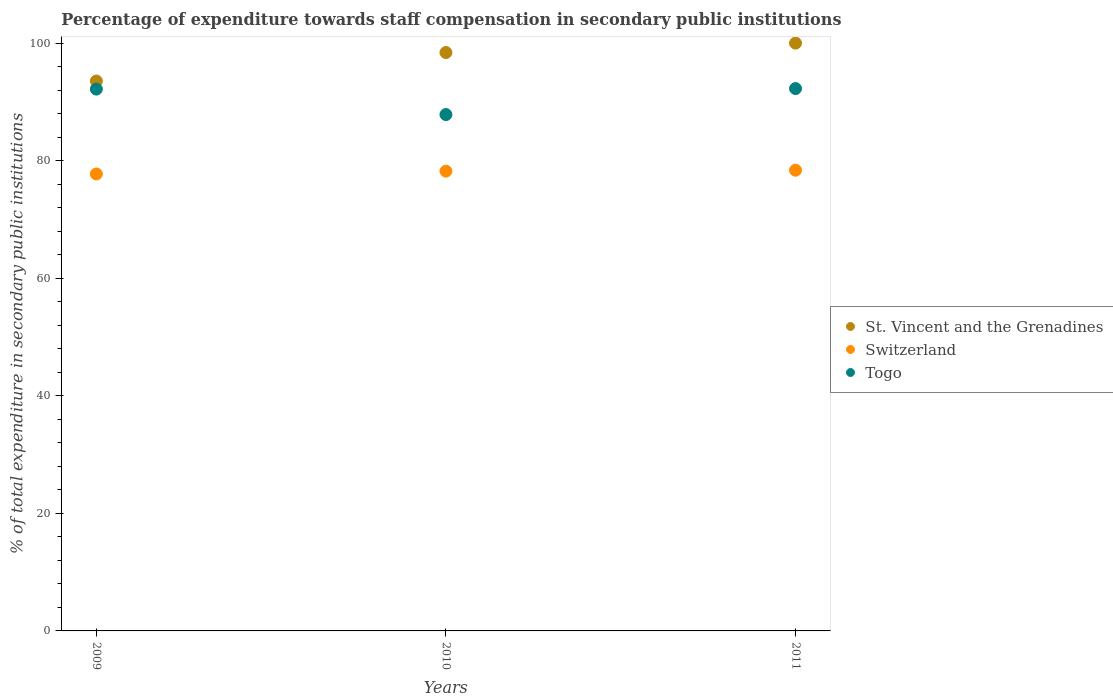How many different coloured dotlines are there?
Provide a short and direct response. 3. What is the percentage of expenditure towards staff compensation in Togo in 2010?
Ensure brevity in your answer.  87.84. Across all years, what is the maximum percentage of expenditure towards staff compensation in Togo?
Your response must be concise. 92.26. Across all years, what is the minimum percentage of expenditure towards staff compensation in Togo?
Your answer should be compact. 87.84. In which year was the percentage of expenditure towards staff compensation in Switzerland maximum?
Make the answer very short. 2011. What is the total percentage of expenditure towards staff compensation in Togo in the graph?
Make the answer very short. 272.29. What is the difference between the percentage of expenditure towards staff compensation in Switzerland in 2009 and that in 2011?
Offer a terse response. -0.64. What is the difference between the percentage of expenditure towards staff compensation in St. Vincent and the Grenadines in 2011 and the percentage of expenditure towards staff compensation in Togo in 2009?
Keep it short and to the point. 7.82. What is the average percentage of expenditure towards staff compensation in Switzerland per year?
Keep it short and to the point. 78.11. In the year 2011, what is the difference between the percentage of expenditure towards staff compensation in St. Vincent and the Grenadines and percentage of expenditure towards staff compensation in Switzerland?
Offer a terse response. 21.62. In how many years, is the percentage of expenditure towards staff compensation in St. Vincent and the Grenadines greater than 56 %?
Your response must be concise. 3. What is the ratio of the percentage of expenditure towards staff compensation in St. Vincent and the Grenadines in 2009 to that in 2010?
Give a very brief answer. 0.95. Is the percentage of expenditure towards staff compensation in St. Vincent and the Grenadines in 2010 less than that in 2011?
Provide a short and direct response. Yes. What is the difference between the highest and the second highest percentage of expenditure towards staff compensation in Togo?
Provide a succinct answer. 0.09. What is the difference between the highest and the lowest percentage of expenditure towards staff compensation in St. Vincent and the Grenadines?
Give a very brief answer. 6.45. In how many years, is the percentage of expenditure towards staff compensation in Togo greater than the average percentage of expenditure towards staff compensation in Togo taken over all years?
Ensure brevity in your answer.  2. Is it the case that in every year, the sum of the percentage of expenditure towards staff compensation in Togo and percentage of expenditure towards staff compensation in St. Vincent and the Grenadines  is greater than the percentage of expenditure towards staff compensation in Switzerland?
Provide a succinct answer. Yes. Is the percentage of expenditure towards staff compensation in St. Vincent and the Grenadines strictly less than the percentage of expenditure towards staff compensation in Switzerland over the years?
Make the answer very short. No. Are the values on the major ticks of Y-axis written in scientific E-notation?
Ensure brevity in your answer.  No. Does the graph contain any zero values?
Provide a short and direct response. No. What is the title of the graph?
Give a very brief answer. Percentage of expenditure towards staff compensation in secondary public institutions. What is the label or title of the X-axis?
Your answer should be very brief. Years. What is the label or title of the Y-axis?
Offer a terse response. % of total expenditure in secondary public institutions. What is the % of total expenditure in secondary public institutions of St. Vincent and the Grenadines in 2009?
Ensure brevity in your answer.  93.55. What is the % of total expenditure in secondary public institutions in Switzerland in 2009?
Provide a succinct answer. 77.74. What is the % of total expenditure in secondary public institutions in Togo in 2009?
Ensure brevity in your answer.  92.18. What is the % of total expenditure in secondary public institutions of St. Vincent and the Grenadines in 2010?
Keep it short and to the point. 98.4. What is the % of total expenditure in secondary public institutions in Switzerland in 2010?
Offer a terse response. 78.22. What is the % of total expenditure in secondary public institutions of Togo in 2010?
Offer a terse response. 87.84. What is the % of total expenditure in secondary public institutions of Switzerland in 2011?
Give a very brief answer. 78.38. What is the % of total expenditure in secondary public institutions in Togo in 2011?
Your answer should be compact. 92.26. Across all years, what is the maximum % of total expenditure in secondary public institutions of St. Vincent and the Grenadines?
Offer a terse response. 100. Across all years, what is the maximum % of total expenditure in secondary public institutions in Switzerland?
Offer a terse response. 78.38. Across all years, what is the maximum % of total expenditure in secondary public institutions in Togo?
Ensure brevity in your answer.  92.26. Across all years, what is the minimum % of total expenditure in secondary public institutions in St. Vincent and the Grenadines?
Your answer should be compact. 93.55. Across all years, what is the minimum % of total expenditure in secondary public institutions in Switzerland?
Ensure brevity in your answer.  77.74. Across all years, what is the minimum % of total expenditure in secondary public institutions in Togo?
Your answer should be compact. 87.84. What is the total % of total expenditure in secondary public institutions of St. Vincent and the Grenadines in the graph?
Your response must be concise. 291.95. What is the total % of total expenditure in secondary public institutions in Switzerland in the graph?
Ensure brevity in your answer.  234.34. What is the total % of total expenditure in secondary public institutions of Togo in the graph?
Keep it short and to the point. 272.29. What is the difference between the % of total expenditure in secondary public institutions of St. Vincent and the Grenadines in 2009 and that in 2010?
Provide a succinct answer. -4.85. What is the difference between the % of total expenditure in secondary public institutions in Switzerland in 2009 and that in 2010?
Offer a terse response. -0.48. What is the difference between the % of total expenditure in secondary public institutions in Togo in 2009 and that in 2010?
Offer a very short reply. 4.33. What is the difference between the % of total expenditure in secondary public institutions of St. Vincent and the Grenadines in 2009 and that in 2011?
Keep it short and to the point. -6.45. What is the difference between the % of total expenditure in secondary public institutions of Switzerland in 2009 and that in 2011?
Your answer should be compact. -0.64. What is the difference between the % of total expenditure in secondary public institutions in Togo in 2009 and that in 2011?
Your response must be concise. -0.09. What is the difference between the % of total expenditure in secondary public institutions of St. Vincent and the Grenadines in 2010 and that in 2011?
Your answer should be compact. -1.6. What is the difference between the % of total expenditure in secondary public institutions in Switzerland in 2010 and that in 2011?
Ensure brevity in your answer.  -0.16. What is the difference between the % of total expenditure in secondary public institutions in Togo in 2010 and that in 2011?
Your answer should be compact. -4.42. What is the difference between the % of total expenditure in secondary public institutions of St. Vincent and the Grenadines in 2009 and the % of total expenditure in secondary public institutions of Switzerland in 2010?
Your answer should be compact. 15.33. What is the difference between the % of total expenditure in secondary public institutions in St. Vincent and the Grenadines in 2009 and the % of total expenditure in secondary public institutions in Togo in 2010?
Provide a succinct answer. 5.7. What is the difference between the % of total expenditure in secondary public institutions in Switzerland in 2009 and the % of total expenditure in secondary public institutions in Togo in 2010?
Provide a short and direct response. -10.11. What is the difference between the % of total expenditure in secondary public institutions of St. Vincent and the Grenadines in 2009 and the % of total expenditure in secondary public institutions of Switzerland in 2011?
Your response must be concise. 15.17. What is the difference between the % of total expenditure in secondary public institutions in St. Vincent and the Grenadines in 2009 and the % of total expenditure in secondary public institutions in Togo in 2011?
Keep it short and to the point. 1.28. What is the difference between the % of total expenditure in secondary public institutions in Switzerland in 2009 and the % of total expenditure in secondary public institutions in Togo in 2011?
Keep it short and to the point. -14.53. What is the difference between the % of total expenditure in secondary public institutions of St. Vincent and the Grenadines in 2010 and the % of total expenditure in secondary public institutions of Switzerland in 2011?
Ensure brevity in your answer.  20.01. What is the difference between the % of total expenditure in secondary public institutions in St. Vincent and the Grenadines in 2010 and the % of total expenditure in secondary public institutions in Togo in 2011?
Provide a short and direct response. 6.13. What is the difference between the % of total expenditure in secondary public institutions in Switzerland in 2010 and the % of total expenditure in secondary public institutions in Togo in 2011?
Your answer should be very brief. -14.05. What is the average % of total expenditure in secondary public institutions of St. Vincent and the Grenadines per year?
Make the answer very short. 97.32. What is the average % of total expenditure in secondary public institutions in Switzerland per year?
Provide a succinct answer. 78.11. What is the average % of total expenditure in secondary public institutions of Togo per year?
Give a very brief answer. 90.76. In the year 2009, what is the difference between the % of total expenditure in secondary public institutions of St. Vincent and the Grenadines and % of total expenditure in secondary public institutions of Switzerland?
Your answer should be very brief. 15.81. In the year 2009, what is the difference between the % of total expenditure in secondary public institutions in St. Vincent and the Grenadines and % of total expenditure in secondary public institutions in Togo?
Ensure brevity in your answer.  1.37. In the year 2009, what is the difference between the % of total expenditure in secondary public institutions of Switzerland and % of total expenditure in secondary public institutions of Togo?
Your answer should be compact. -14.44. In the year 2010, what is the difference between the % of total expenditure in secondary public institutions of St. Vincent and the Grenadines and % of total expenditure in secondary public institutions of Switzerland?
Your answer should be compact. 20.18. In the year 2010, what is the difference between the % of total expenditure in secondary public institutions in St. Vincent and the Grenadines and % of total expenditure in secondary public institutions in Togo?
Provide a short and direct response. 10.55. In the year 2010, what is the difference between the % of total expenditure in secondary public institutions in Switzerland and % of total expenditure in secondary public institutions in Togo?
Give a very brief answer. -9.63. In the year 2011, what is the difference between the % of total expenditure in secondary public institutions in St. Vincent and the Grenadines and % of total expenditure in secondary public institutions in Switzerland?
Offer a very short reply. 21.62. In the year 2011, what is the difference between the % of total expenditure in secondary public institutions in St. Vincent and the Grenadines and % of total expenditure in secondary public institutions in Togo?
Provide a short and direct response. 7.74. In the year 2011, what is the difference between the % of total expenditure in secondary public institutions of Switzerland and % of total expenditure in secondary public institutions of Togo?
Make the answer very short. -13.88. What is the ratio of the % of total expenditure in secondary public institutions of St. Vincent and the Grenadines in 2009 to that in 2010?
Give a very brief answer. 0.95. What is the ratio of the % of total expenditure in secondary public institutions of Togo in 2009 to that in 2010?
Your answer should be very brief. 1.05. What is the ratio of the % of total expenditure in secondary public institutions of St. Vincent and the Grenadines in 2009 to that in 2011?
Provide a short and direct response. 0.94. What is the ratio of the % of total expenditure in secondary public institutions in St. Vincent and the Grenadines in 2010 to that in 2011?
Offer a very short reply. 0.98. What is the ratio of the % of total expenditure in secondary public institutions in Switzerland in 2010 to that in 2011?
Your answer should be compact. 1. What is the ratio of the % of total expenditure in secondary public institutions of Togo in 2010 to that in 2011?
Provide a succinct answer. 0.95. What is the difference between the highest and the second highest % of total expenditure in secondary public institutions in St. Vincent and the Grenadines?
Give a very brief answer. 1.6. What is the difference between the highest and the second highest % of total expenditure in secondary public institutions in Switzerland?
Ensure brevity in your answer.  0.16. What is the difference between the highest and the second highest % of total expenditure in secondary public institutions in Togo?
Provide a succinct answer. 0.09. What is the difference between the highest and the lowest % of total expenditure in secondary public institutions in St. Vincent and the Grenadines?
Offer a terse response. 6.45. What is the difference between the highest and the lowest % of total expenditure in secondary public institutions in Switzerland?
Keep it short and to the point. 0.64. What is the difference between the highest and the lowest % of total expenditure in secondary public institutions in Togo?
Your answer should be very brief. 4.42. 